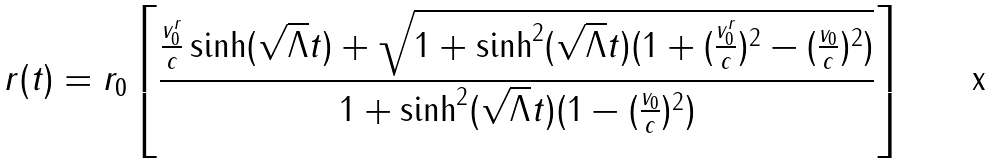<formula> <loc_0><loc_0><loc_500><loc_500>r ( t ) = r _ { 0 } \left [ \frac { \frac { v _ { 0 } ^ { r } } { c } \sinh ( \sqrt { \Lambda } t ) + \sqrt { 1 + \sinh ^ { 2 } ( \sqrt { \Lambda } t ) ( 1 + ( \frac { v _ { 0 } ^ { r } } { c } ) ^ { 2 } - ( \frac { v _ { 0 } } { c } ) ^ { 2 } ) } } { 1 + \sinh ^ { 2 } ( \sqrt { \Lambda } t ) ( 1 - ( \frac { v _ { 0 } } { c } ) ^ { 2 } ) } \right ]</formula> 